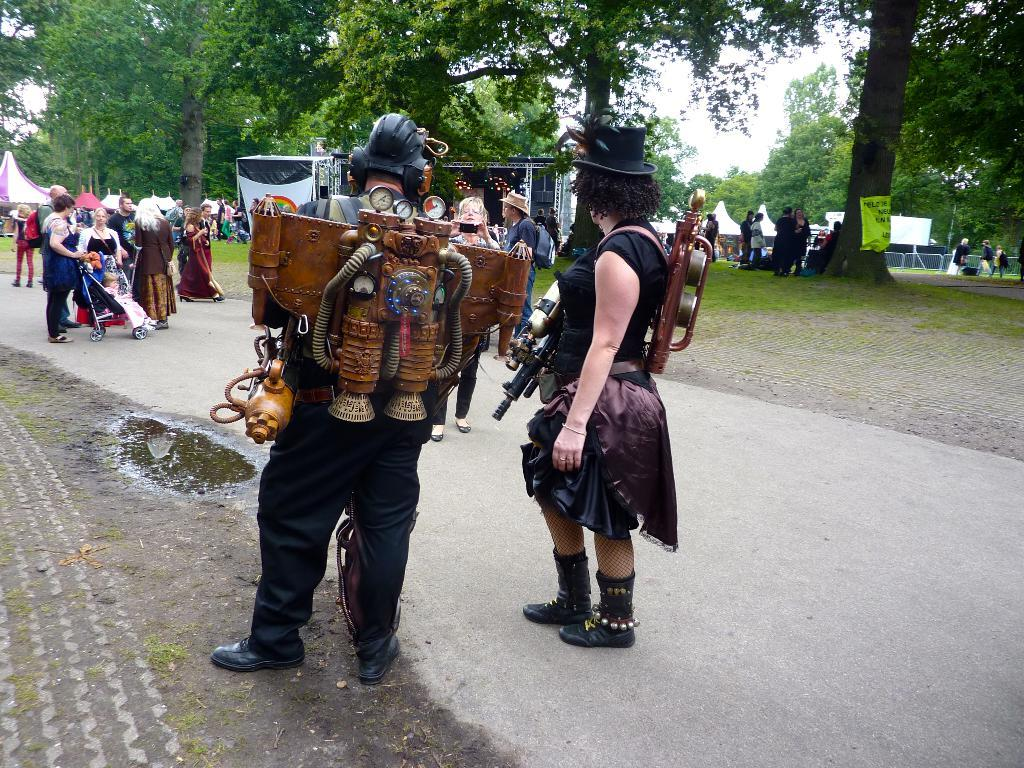Where was the picture taken? The picture was taken outside. What is the main focus of the image? There is a group of people in the center of the image. What can be seen in the background of the image? There are tents, the sky, trees, and other unspecified objects in the background of the image. What type of plants can be seen growing in the basket in the image? There is no basket or plants present in the image. 